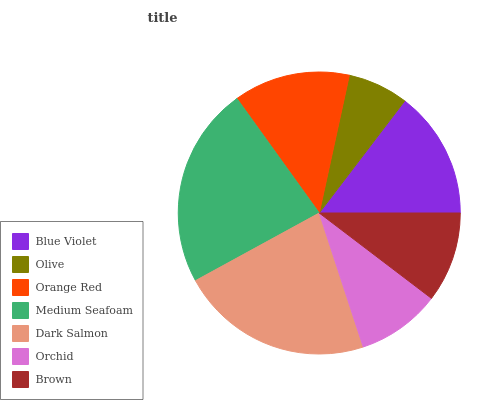Is Olive the minimum?
Answer yes or no. Yes. Is Medium Seafoam the maximum?
Answer yes or no. Yes. Is Orange Red the minimum?
Answer yes or no. No. Is Orange Red the maximum?
Answer yes or no. No. Is Orange Red greater than Olive?
Answer yes or no. Yes. Is Olive less than Orange Red?
Answer yes or no. Yes. Is Olive greater than Orange Red?
Answer yes or no. No. Is Orange Red less than Olive?
Answer yes or no. No. Is Orange Red the high median?
Answer yes or no. Yes. Is Orange Red the low median?
Answer yes or no. Yes. Is Orchid the high median?
Answer yes or no. No. Is Olive the low median?
Answer yes or no. No. 